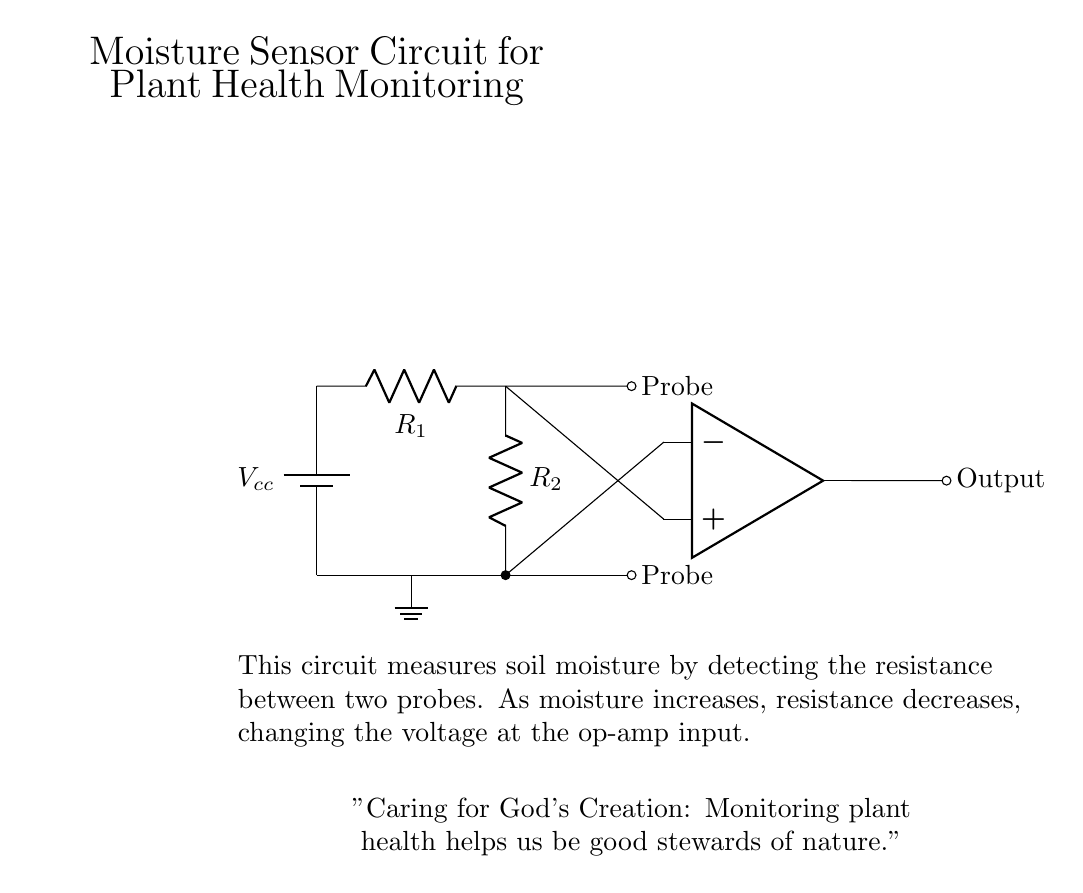What is the power source for this circuit? The power source is represented by the battery symbol labeled as Vcc, which indicates the circuit's supply voltage.
Answer: Vcc What do the two probes measure in this circuit? The two probes measure the soil moisture by detecting the resistance between them; moisture alters resistance, informing the circuit of moisture levels.
Answer: Soil moisture What component processes the voltage signal from the probes? The operational amplifier, shown in the diagram, receives the voltage signal from the probes and amplifies it for output.
Answer: Op-amp What is the role of the resistors in this circuit? The resistors R1 and R2 assist in defining the voltage divider configuration that ultimately determines the signals sent to the op-amp based on soil moisture resistance.
Answer: Voltage divider How does moisture level affect the output voltage? As the moisture content increases, the resistance between the probes decreases, leading to a change in the voltage at the input of the op-amp, which modifies the output voltage accordingly.
Answer: It increases output voltage What does an increased output voltage indicate? An increased output voltage suggests higher soil moisture levels, signaling that the plants might be receiving adequate water, critical for maintaining plant health.
Answer: Higher moisture What is the importance of monitoring plant health in relation to faith? Monitoring plant health aligns with the value of stewardship in faith, emphasizing the duty to care for God's creation and the environment thoughtfully.
Answer: Stewardship of nature 